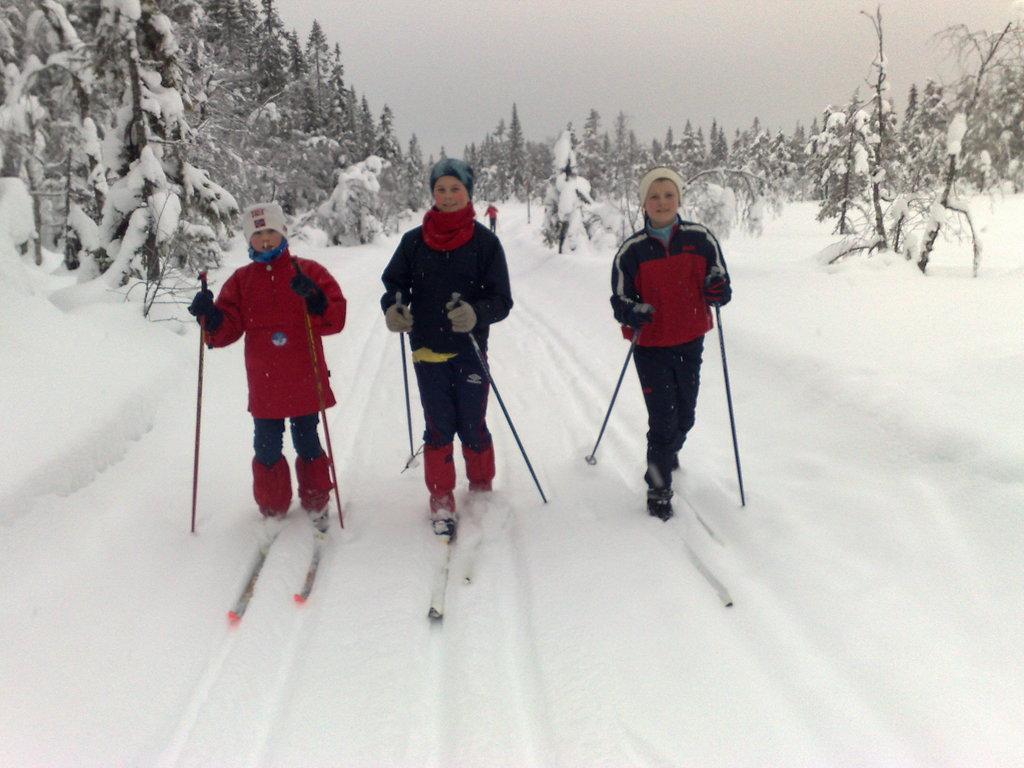Can you describe this image briefly? This picture is clicked outside. In the center we can see the three persons skiing on the ski-boards and we can see there is a lot of snow and we can see the trees and the sky and some other objects. 